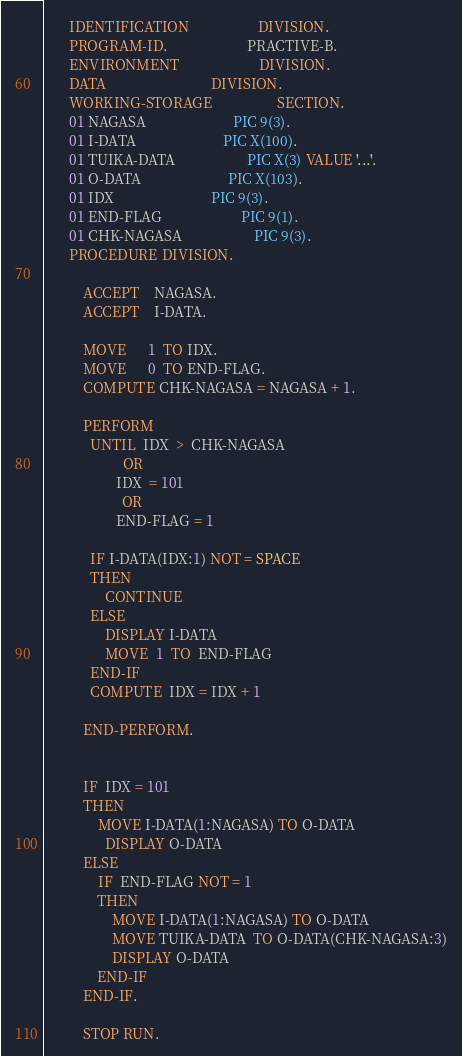<code> <loc_0><loc_0><loc_500><loc_500><_COBOL_>       IDENTIFICATION                   DIVISION.
       PROGRAM-ID.                      PRACTIVE-B.
       ENVIRONMENT                      DIVISION.
       DATA                             DIVISION.
       WORKING-STORAGE                  SECTION.
       01 NAGASA                        PIC 9(3).
       01 I-DATA                        PIC X(100).
       01 TUIKA-DATA                    PIC X(3) VALUE '...'.
       01 O-DATA                        PIC X(103).
       01 IDX                           PIC 9(3).
       01 END-FLAG                      PIC 9(1).
       01 CHK-NAGASA                    PIC 9(3).
       PROCEDURE DIVISION.

           ACCEPT    NAGASA.
           ACCEPT    I-DATA.

           MOVE      1  TO IDX.
           MOVE      0  TO END-FLAG.
           COMPUTE CHK-NAGASA = NAGASA + 1.
      
           PERFORM  
             UNTIL  IDX  >  CHK-NAGASA 
                      OR
                    IDX  = 101
                      OR
                    END-FLAG = 1
      
      		 IF I-DATA(IDX:1) NOT = SPACE
             THEN
      		     CONTINUE
             ELSE
                 DISPLAY I-DATA
                 MOVE  1  TO  END-FLAG
             END-IF
             COMPUTE  IDX = IDX + 1
      
           END-PERFORM.
      
      
           IF  IDX = 101
           THEN
          	   MOVE I-DATA(1:NAGASA) TO O-DATA
           	   DISPLAY O-DATA
           ELSE
               IF  END-FLAG NOT = 1
               THEN
                   MOVE I-DATA(1:NAGASA) TO O-DATA
                   MOVE TUIKA-DATA  TO O-DATA(CHK-NAGASA:3)
                   DISPLAY O-DATA
               END-IF
           END-IF.

           STOP RUN.</code> 